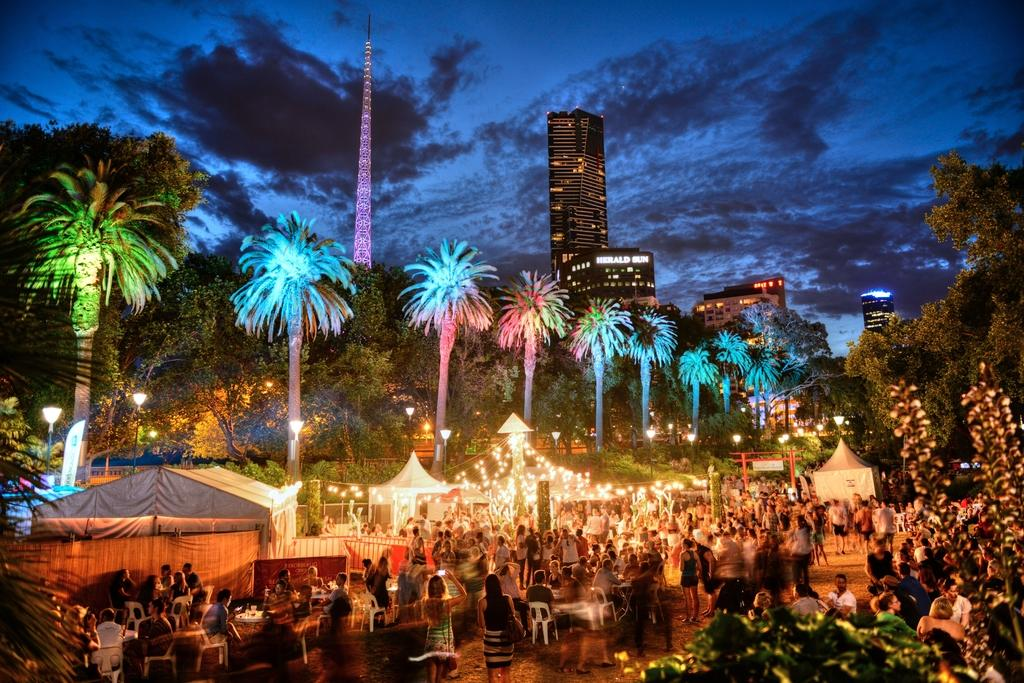What is the weather like in the image? The sky is cloudy in the image. What type of structures can be seen in the image? There are buildings with windows in the image. What are some other objects present in the image? There are light poles, trees in the background, tents, and lights visible in the image. What are the people in the image doing? Some people are sitting on chairs in the image. Can you see any toys on the seashore in the image? There is no seashore or toys present in the image. Is there a donkey visible in the image? There is no donkey present in the image. 